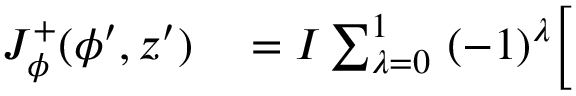<formula> <loc_0><loc_0><loc_500><loc_500>\begin{array} { r l } { J _ { \phi } ^ { + } ( \phi ^ { \prime } , z ^ { \prime } ) } & = I \sum _ { \lambda = 0 } ^ { 1 } \ ( - 1 ) ^ { \lambda } \Big [ } \end{array}</formula> 